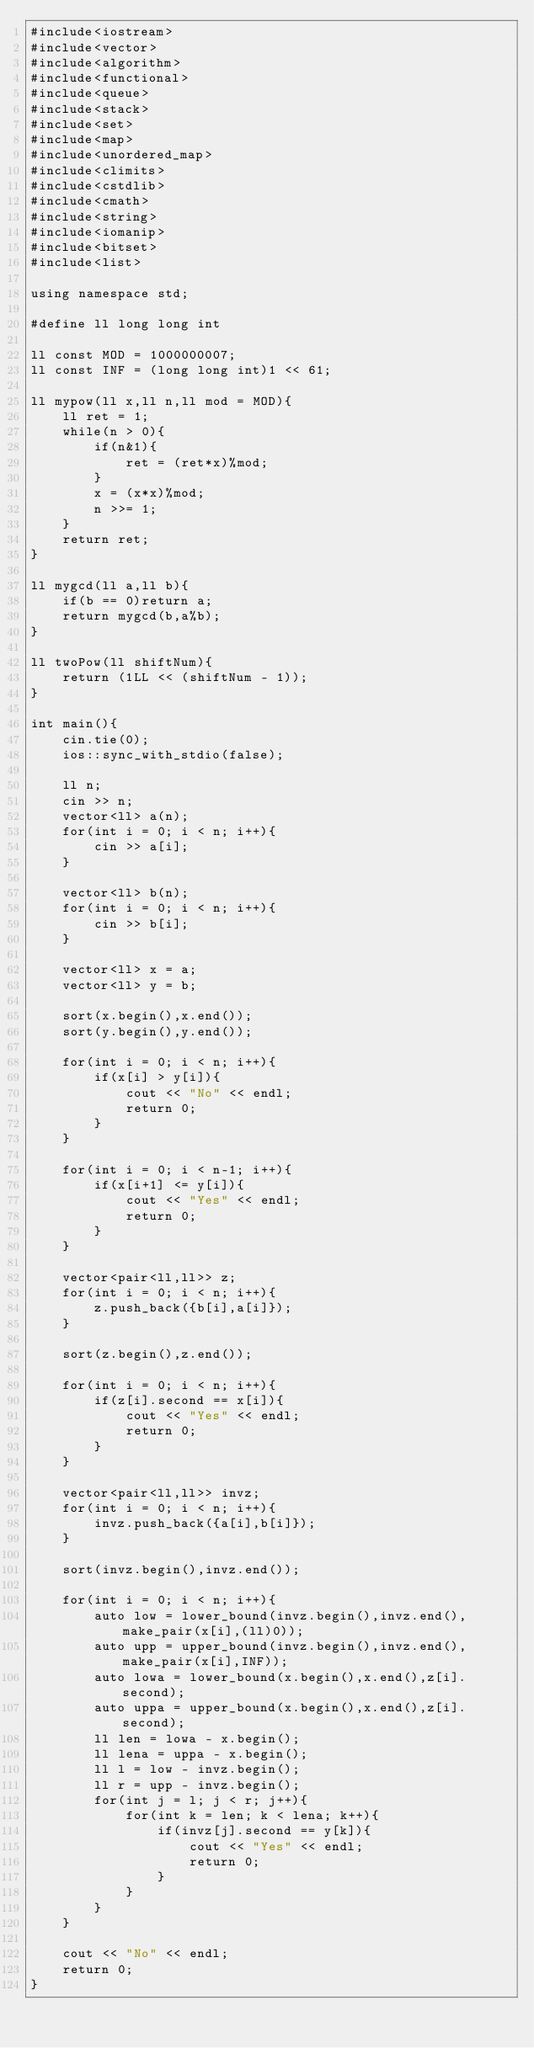<code> <loc_0><loc_0><loc_500><loc_500><_C++_>#include<iostream>
#include<vector>
#include<algorithm>
#include<functional>
#include<queue>
#include<stack>
#include<set>
#include<map>
#include<unordered_map>
#include<climits>
#include<cstdlib>
#include<cmath>
#include<string>
#include<iomanip>
#include<bitset>
#include<list>

using namespace std;

#define ll long long int

ll const MOD = 1000000007;
ll const INF = (long long int)1 << 61;

ll mypow(ll x,ll n,ll mod = MOD){
    ll ret = 1;
    while(n > 0){
        if(n&1){
            ret = (ret*x)%mod;
        }
        x = (x*x)%mod;
        n >>= 1;
    }
    return ret;
}

ll mygcd(ll a,ll b){
    if(b == 0)return a;
    return mygcd(b,a%b);
}

ll twoPow(ll shiftNum){
    return (1LL << (shiftNum - 1));
}

int main(){
    cin.tie(0);
    ios::sync_with_stdio(false);
 
    ll n;
    cin >> n;
    vector<ll> a(n);
    for(int i = 0; i < n; i++){
        cin >> a[i];
    }

    vector<ll> b(n);
    for(int i = 0; i < n; i++){
        cin >> b[i];
    }

    vector<ll> x = a;
    vector<ll> y = b;

    sort(x.begin(),x.end());
    sort(y.begin(),y.end());

    for(int i = 0; i < n; i++){
        if(x[i] > y[i]){
            cout << "No" << endl;
            return 0;
        }
    }

    for(int i = 0; i < n-1; i++){
        if(x[i+1] <= y[i]){
            cout << "Yes" << endl;
            return 0;
        }
    }

    vector<pair<ll,ll>> z;
    for(int i = 0; i < n; i++){
        z.push_back({b[i],a[i]});
    }

    sort(z.begin(),z.end());

    for(int i = 0; i < n; i++){
        if(z[i].second == x[i]){
            cout << "Yes" << endl;
            return 0;
        }
    }

    vector<pair<ll,ll>> invz;
    for(int i = 0; i < n; i++){
        invz.push_back({a[i],b[i]});
    }

    sort(invz.begin(),invz.end());

    for(int i = 0; i < n; i++){
        auto low = lower_bound(invz.begin(),invz.end(),make_pair(x[i],(ll)0));
        auto upp = upper_bound(invz.begin(),invz.end(),make_pair(x[i],INF));
        auto lowa = lower_bound(x.begin(),x.end(),z[i].second);
        auto uppa = upper_bound(x.begin(),x.end(),z[i].second);
        ll len = lowa - x.begin();
        ll lena = uppa - x.begin();
        ll l = low - invz.begin();
        ll r = upp - invz.begin();
        for(int j = l; j < r; j++){
            for(int k = len; k < lena; k++){
                if(invz[j].second == y[k]){
                    cout << "Yes" << endl;
                    return 0;
                }
            }
        }
    }

    cout << "No" << endl;
    return 0;
}</code> 